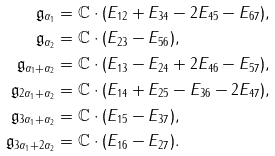Convert formula to latex. <formula><loc_0><loc_0><loc_500><loc_500>\mathfrak { g } _ { \alpha _ { 1 } } & = \mathbb { C } \cdot ( E _ { 1 2 } + E _ { 3 4 } - 2 E _ { 4 5 } - E _ { 6 7 } ) , \\ \mathfrak { g } _ { \alpha _ { 2 } } & = \mathbb { C } \cdot ( E _ { 2 3 } - E _ { 5 6 } ) , \\ \mathfrak { g } _ { \alpha _ { 1 } + \alpha _ { 2 } } & = \mathbb { C } \cdot ( E _ { 1 3 } - E _ { 2 4 } + 2 E _ { 4 6 } - E _ { 5 7 } ) , \\ \mathfrak { g } _ { 2 \alpha _ { 1 } + \alpha _ { 2 } } & = \mathbb { C } \cdot ( E _ { 1 4 } + E _ { 2 5 } - E _ { 3 6 } - 2 E _ { 4 7 } ) , \\ \mathfrak { g } _ { 3 \alpha _ { 1 } + \alpha _ { 2 } } & = \mathbb { C } \cdot ( E _ { 1 5 } - E _ { 3 7 } ) , \\ \mathfrak { g } _ { 3 \alpha _ { 1 } + 2 \alpha _ { 2 } } & = \mathbb { C } \cdot ( E _ { 1 6 } - E _ { 2 7 } ) .</formula> 